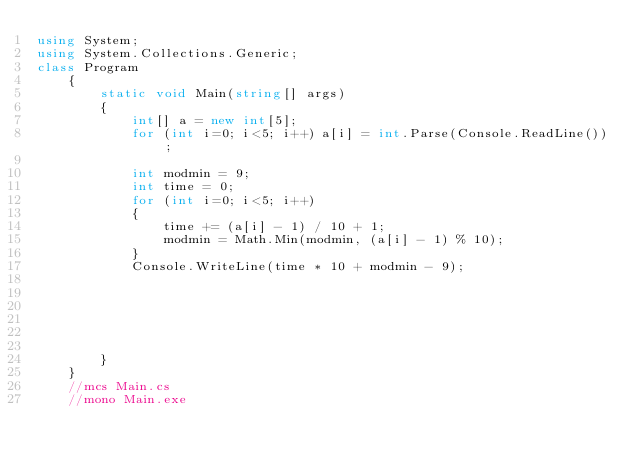<code> <loc_0><loc_0><loc_500><loc_500><_C#_>using System;
using System.Collections.Generic;
class Program
    {
        static void Main(string[] args)
        {
            int[] a = new int[5];
            for (int i=0; i<5; i++) a[i] = int.Parse(Console.ReadLine());

            int modmin = 9;
            int time = 0;
            for (int i=0; i<5; i++)
            {
                time += (a[i] - 1) / 10 + 1;
                modmin = Math.Min(modmin, (a[i] - 1) % 10);
            }
            Console.WriteLine(time * 10 + modmin - 9);

            
            


            
        }
    }
    //mcs Main.cs
    //mono Main.exe</code> 